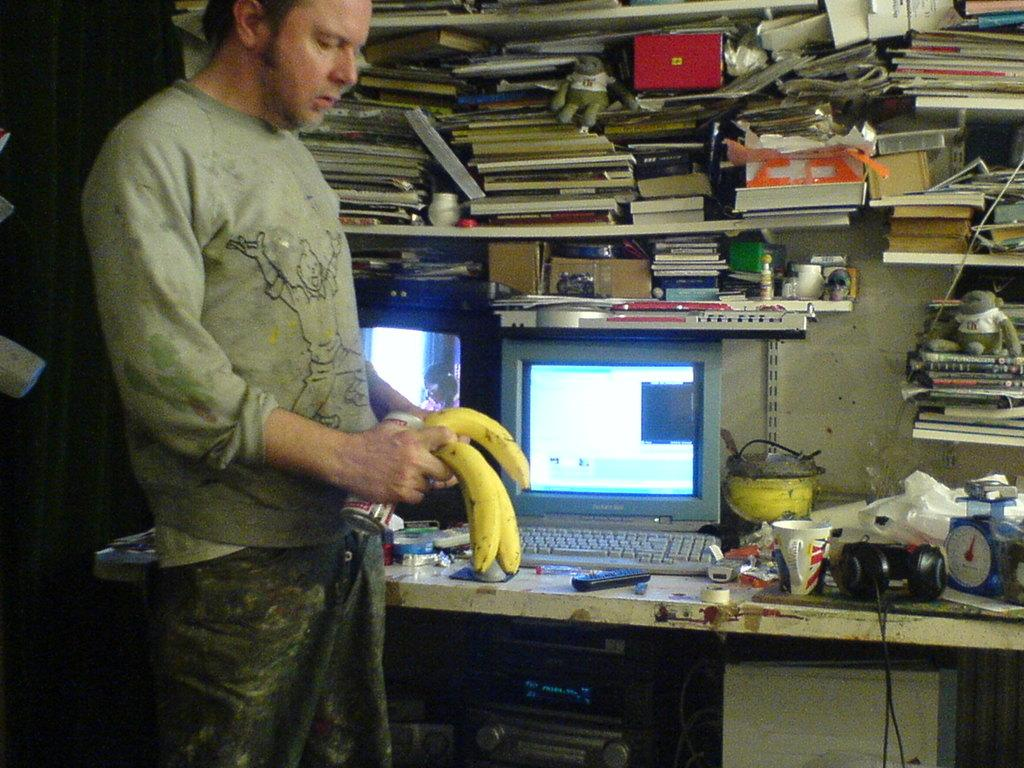What is the man holding in the image? The man is holding bananas in the image. What can be seen behind the man? There is a wall in the image. What items are visible on the shelves in the image? The shelves are filled with books in the image. What objects are present on the table in the image? There is a headset, a mug, a remote, a screen, a clock, and a pot on the table in the image. Is there a crib visible in the image? No, there is no crib present in the image. What type of gun is the man holding in the image? There is no gun present in the image; the man is holding bananas. 